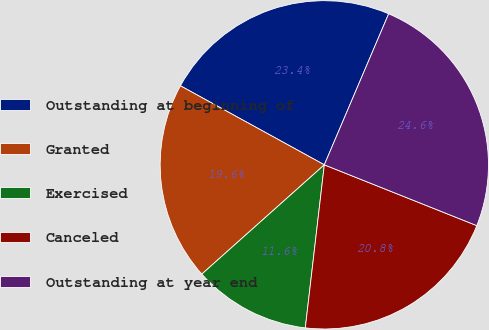Convert chart. <chart><loc_0><loc_0><loc_500><loc_500><pie_chart><fcel>Outstanding at beginning of<fcel>Granted<fcel>Exercised<fcel>Canceled<fcel>Outstanding at year end<nl><fcel>23.42%<fcel>19.59%<fcel>11.56%<fcel>20.81%<fcel>24.63%<nl></chart> 